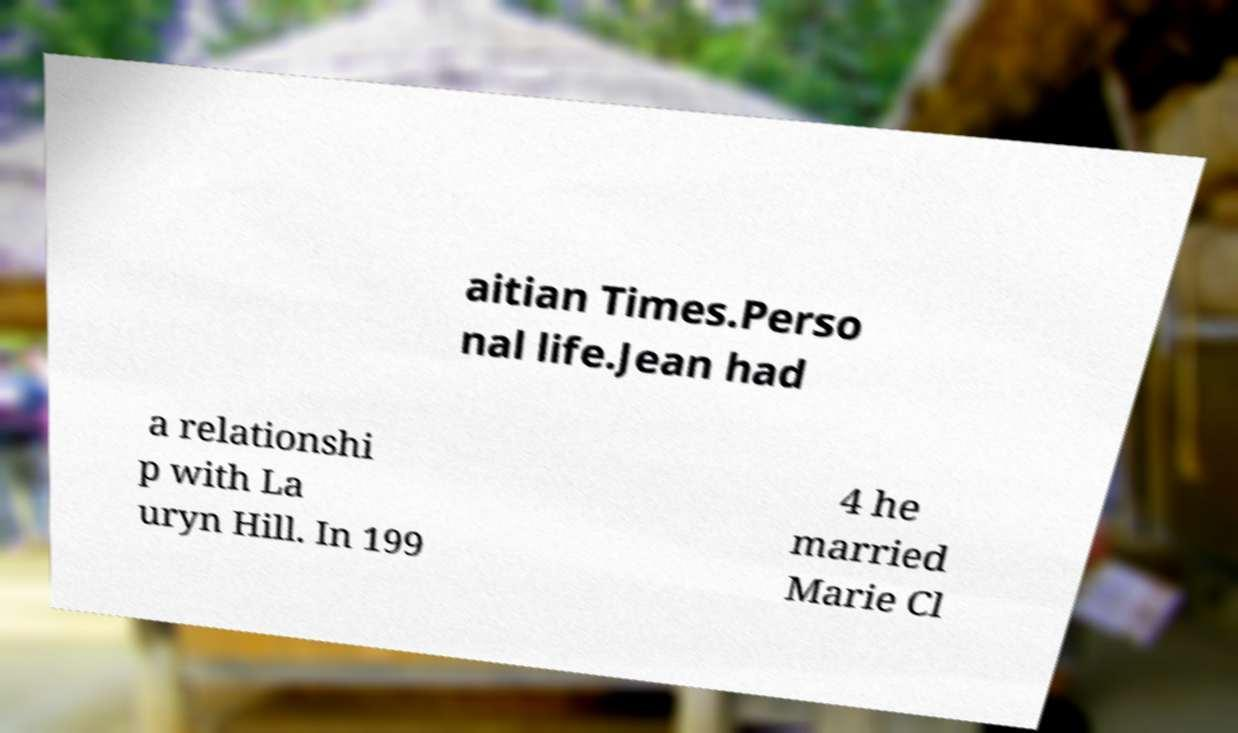Can you accurately transcribe the text from the provided image for me? aitian Times.Perso nal life.Jean had a relationshi p with La uryn Hill. In 199 4 he married Marie Cl 